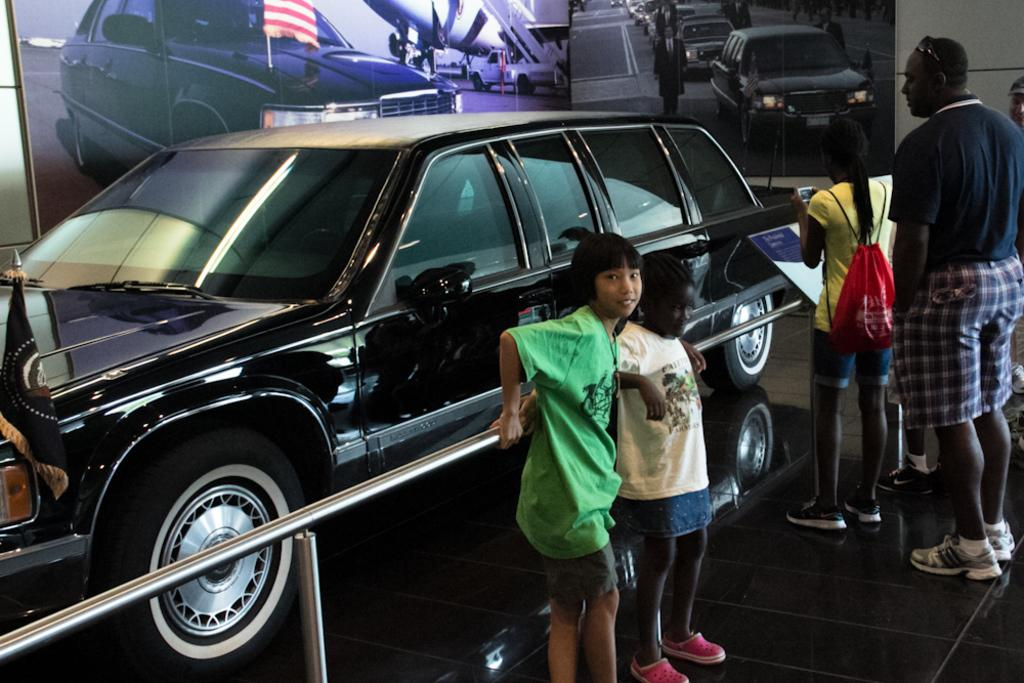What is the main subject of the image? There is a vehicle in the image. What else can be seen in the image besides the vehicle? There are people on the ground, a fence, and various objects in the image. What is visible in the background of the image? There is a wall and a screen in the background of the image. What type of copper or brass object can be seen in the image? There is no copper or brass object present in the image. What event is taking place in the image? The image does not depict a specific event; it simply shows a vehicle, people, a fence, objects, a wall, and a screen. 